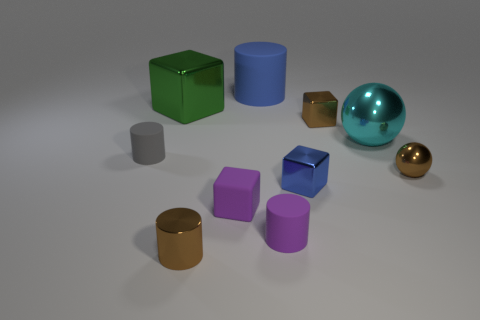Subtract all tiny gray cylinders. How many cylinders are left? 3 Subtract all blocks. How many objects are left? 6 Subtract all brown spheres. How many spheres are left? 1 Subtract 2 cylinders. How many cylinders are left? 2 Subtract all brown objects. Subtract all metallic things. How many objects are left? 1 Add 3 small matte cylinders. How many small matte cylinders are left? 5 Add 6 blue shiny cubes. How many blue shiny cubes exist? 7 Subtract 1 green cubes. How many objects are left? 9 Subtract all red spheres. Subtract all red cylinders. How many spheres are left? 2 Subtract all red blocks. How many brown cylinders are left? 1 